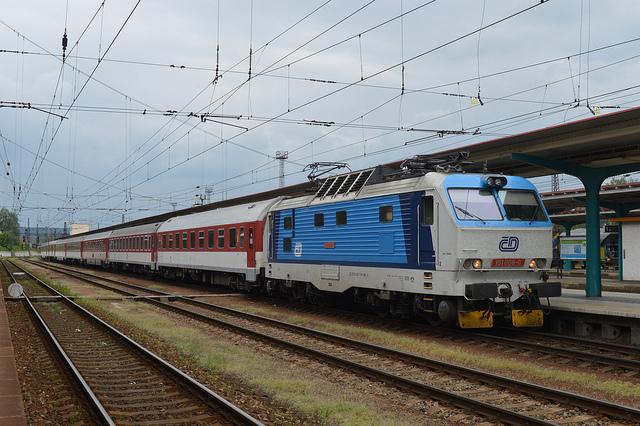What is the color of the second box car?
Write a very short answer. Red and white. How many rails are there?
Concise answer only. 3. How many sets of tracks are there?
Be succinct. 3. What number is written on the first train car?
Quick response, please. 7. What color is the train?
Be succinct. Blue. Is the train leaving or arriving?
Short answer required. Arriving. How many sets of track are there?
Keep it brief. 3. How many trains are there?
Quick response, please. 1. How many train cars?
Answer briefly. 8. Is it raining?
Be succinct. No. Has the train completely passed through the tunnel?
Concise answer only. No. What color is the front of the engine?
Concise answer only. Blue and white. Is the train moving?
Keep it brief. No. What 3 is on the left of the picture?
Answer briefly. 0. Does the train look round?
Write a very short answer. No. What color is the bottom of the train?
Write a very short answer. White. Is the train at the station?
Be succinct. Yes. Is this vehicle currently being used for human transportation?
Answer briefly. Yes. How many train tracks are there?
Concise answer only. 3. Is the sky clear?
Write a very short answer. No. What color is the front of the train?
Be succinct. White and blue. How many tracks are there?
Write a very short answer. 3. What type of service does this train provide?
Write a very short answer. Passenger. How many cars are on this train?
Write a very short answer. 8. What is the train doing?
Be succinct. Stopping. What color is the vehicle next to the train?
Keep it brief. Blue. 